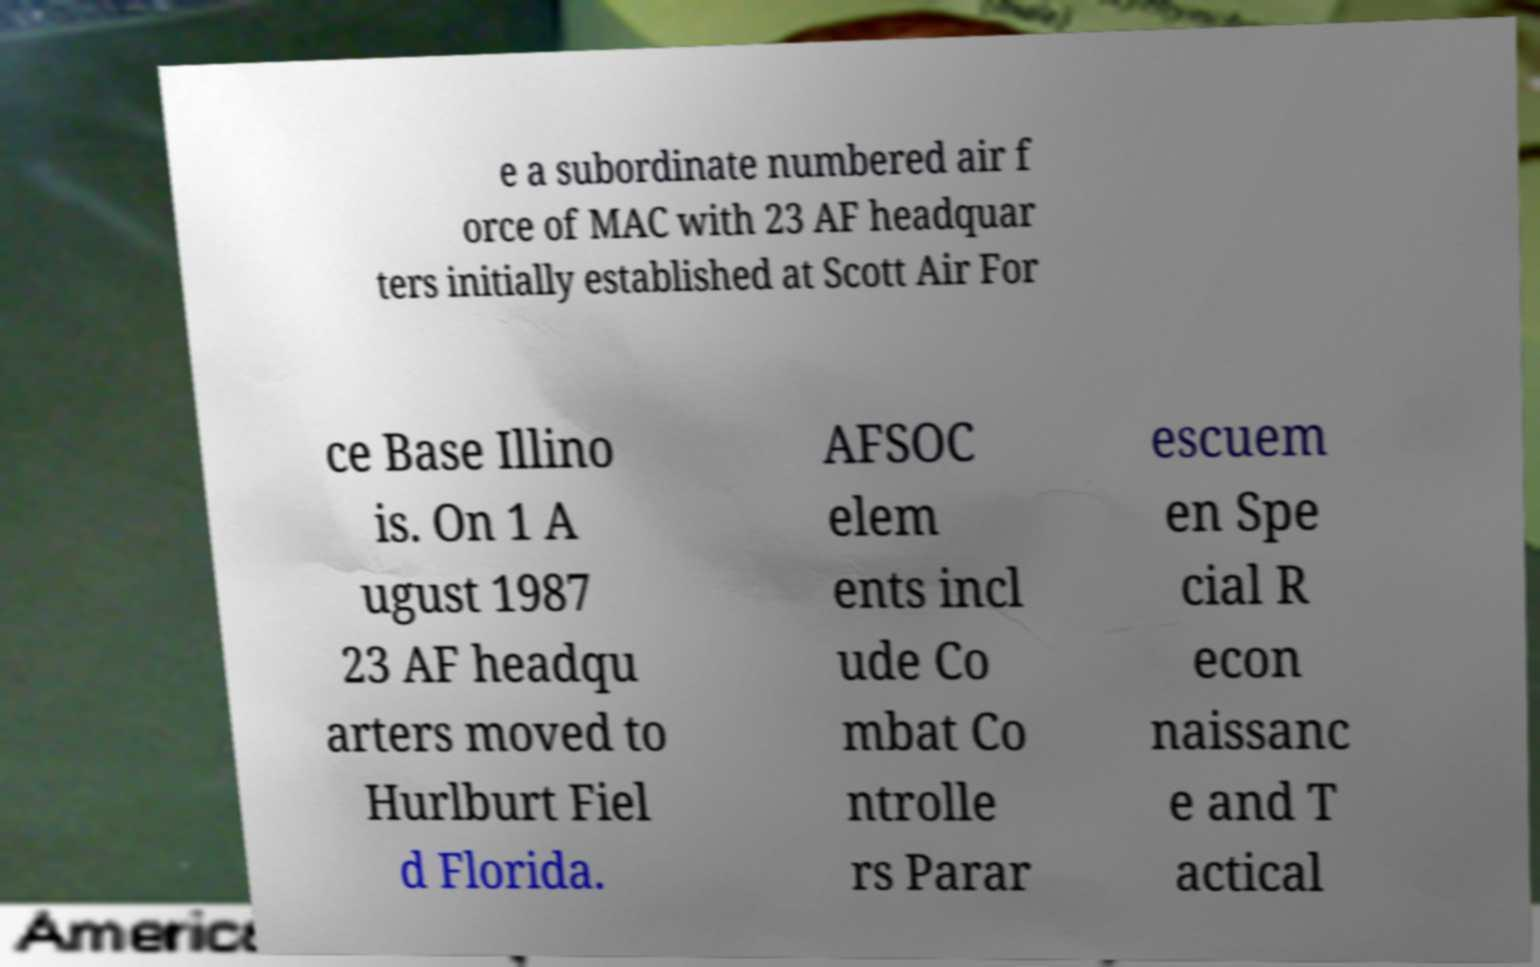Could you assist in decoding the text presented in this image and type it out clearly? e a subordinate numbered air f orce of MAC with 23 AF headquar ters initially established at Scott Air For ce Base Illino is. On 1 A ugust 1987 23 AF headqu arters moved to Hurlburt Fiel d Florida. AFSOC elem ents incl ude Co mbat Co ntrolle rs Parar escuem en Spe cial R econ naissanc e and T actical 